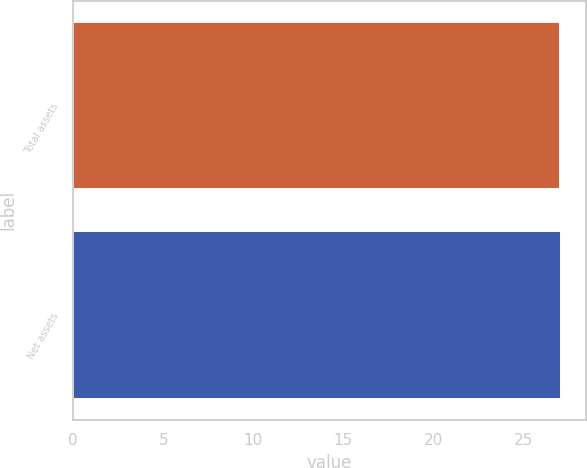<chart> <loc_0><loc_0><loc_500><loc_500><bar_chart><fcel>Total assets<fcel>Net assets<nl><fcel>27<fcel>27.1<nl></chart> 